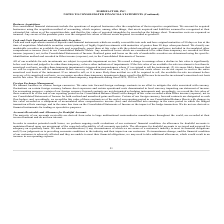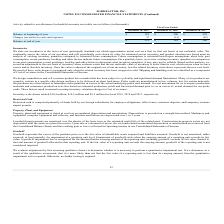According to Formfactor's financial document, What is the main source of accounts receivable? derived from sales to large multinational semiconductor manufacturers throughout the world. The document states: "ounts The majority of our accounts receivable are derived from sales to large multinational semiconductor manufacturers throughout the world, are reco..." Also, can you calculate: What is the change in allowance Balance at beginning of year from Fiscal Year Ended December 28, 2019 to December 29, 2018? Based on the calculation: 185-200, the result is -15 (in thousands). This is based on the information: "Balance at beginning of year $ 185 $ 200 $ 299 Balance at beginning of year $ 185 $ 200 $ 299..." The key data points involved are: 185, 200. Also, can you calculate: What is the change in allowance Charges (reversals) to costs and expenses from Fiscal Year Ended December 28, 2019 to December 29, 2018? Based on the calculation: 37-(15), the result is 52 (in thousands). This is based on the information: "Charges (reversals) to costs and expenses 37 (15) (99) Charges (reversals) to costs and expenses 37 (15) (99)..." The key data points involved are: 15, 37. Additionally, In which year was Balance at beginning of year less than 200 thousands? According to the financial document, 2019. The relevant text states: "December 28, 2019 December 29, 2018 December 30, 2017..." Also, What was the Charges (reversals) to costs and expenses in 2019, 2018 and 2017 respectively? The document contains multiple relevant values: 37, (15), (99) (in thousands). From the document: "Charges (reversals) to costs and expenses 37 (15) (99) Charges (reversals) to costs and expenses 37 (15) (99) Charges (reversals) to costs and expense..." Also, How does the company monitor the potential credit loss? we perform ongoing credit evaluations of our customers' financial condition. The document states: "In order to monitor potential credit losses, we perform ongoing credit evaluations of our customers' financial condition. An allowance for doubtful ac..." 